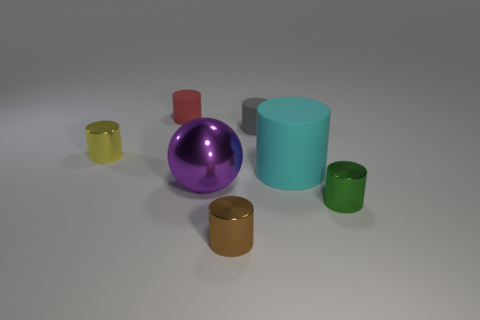Subtract all brown cylinders. How many cylinders are left? 5 Subtract all brown metal cylinders. How many cylinders are left? 5 Subtract all brown cylinders. Subtract all green cubes. How many cylinders are left? 5 Add 3 red things. How many objects exist? 10 Subtract all cylinders. How many objects are left? 1 Add 3 small brown shiny things. How many small brown shiny things exist? 4 Subtract 0 red cubes. How many objects are left? 7 Subtract all large cyan shiny cylinders. Subtract all matte things. How many objects are left? 4 Add 6 tiny green cylinders. How many tiny green cylinders are left? 7 